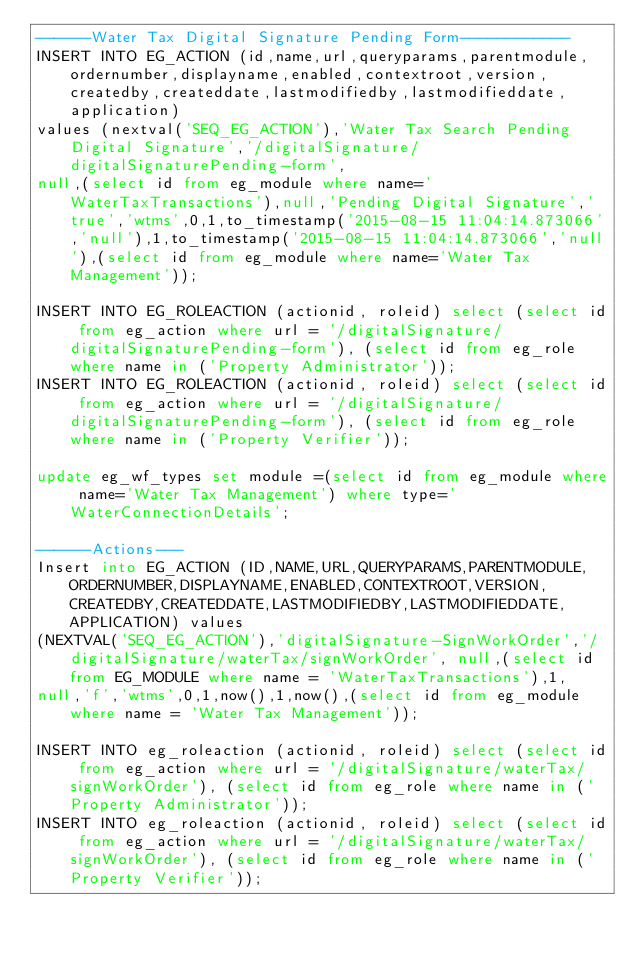Convert code to text. <code><loc_0><loc_0><loc_500><loc_500><_SQL_>------Water Tax Digital Signature Pending Form------------
INSERT INTO EG_ACTION (id,name,url,queryparams,parentmodule,ordernumber,displayname,enabled,contextroot,version,createdby,createddate,lastmodifiedby,lastmodifieddate,application) 
values (nextval('SEQ_EG_ACTION'),'Water Tax Search Pending Digital Signature','/digitalSignature/digitalSignaturePending-form',
null,(select id from eg_module where name='WaterTaxTransactions'),null,'Pending Digital Signature','true','wtms',0,1,to_timestamp('2015-08-15 11:04:14.873066','null'),1,to_timestamp('2015-08-15 11:04:14.873066','null'),(select id from eg_module where name='Water Tax Management'));

INSERT INTO EG_ROLEACTION (actionid, roleid) select (select id from eg_action where url = '/digitalSignature/digitalSignaturePending-form'), (select id from eg_role where name in ('Property Administrator'));
INSERT INTO EG_ROLEACTION (actionid, roleid) select (select id from eg_action where url = '/digitalSignature/digitalSignaturePending-form'), (select id from eg_role where name in ('Property Verifier'));

update eg_wf_types set module =(select id from eg_module where name='Water Tax Management') where type='WaterConnectionDetails';

------Actions---
Insert into EG_ACTION (ID,NAME,URL,QUERYPARAMS,PARENTMODULE,ORDERNUMBER,DISPLAYNAME,ENABLED,CONTEXTROOT,VERSION,CREATEDBY,CREATEDDATE,LASTMODIFIEDBY,LASTMODIFIEDDATE,APPLICATION) values 
(NEXTVAL('SEQ_EG_ACTION'),'digitalSignature-SignWorkOrder','/digitalSignature/waterTax/signWorkOrder', null,(select id from EG_MODULE where name = 'WaterTaxTransactions'),1,
null,'f','wtms',0,1,now(),1,now(),(select id from eg_module  where name = 'Water Tax Management'));

INSERT INTO eg_roleaction (actionid, roleid) select (select id from eg_action where url = '/digitalSignature/waterTax/signWorkOrder'), (select id from eg_role where name in ('Property Administrator'));
INSERT INTO eg_roleaction (actionid, roleid) select (select id from eg_action where url = '/digitalSignature/waterTax/signWorkOrder'), (select id from eg_role where name in ('Property Verifier'));</code> 